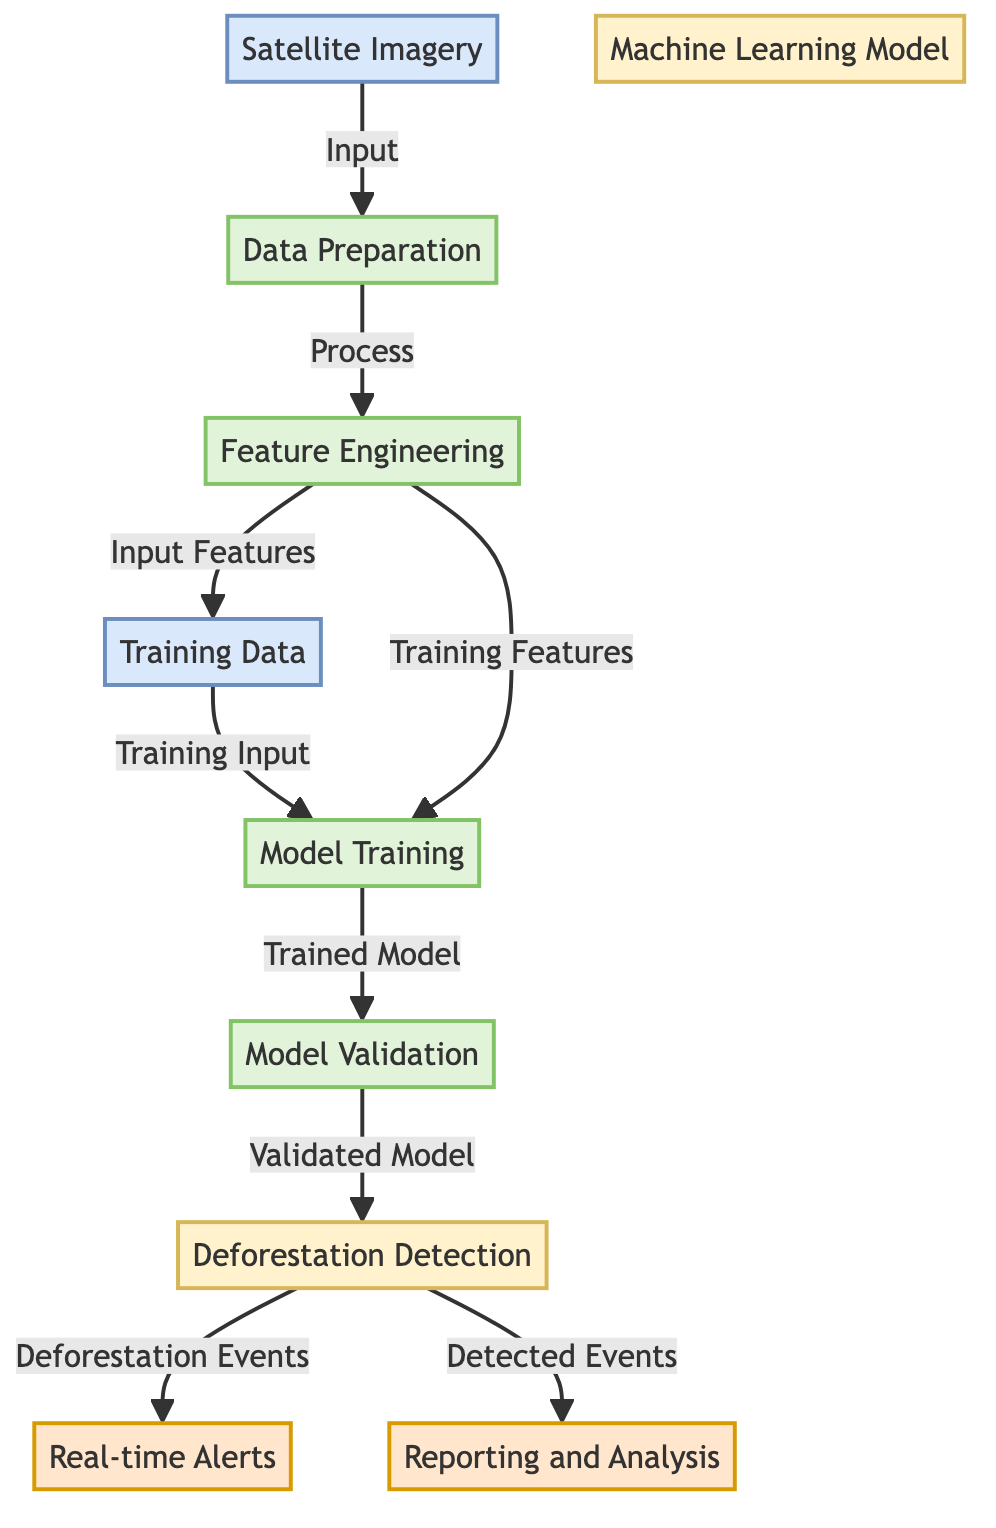what is the first step in the diagram? The first step in the diagram is "Satellite Imagery", which refers to the input data collected from satellites that is necessary for the entire process.
Answer: Satellite Imagery how many output nodes are there in the diagram? The diagram contains two output nodes: "Real-time Alerts" and "Reporting and Analysis," which provide results of the deforestation detection model.
Answer: 2 which process directly follows data preparation? The process that directly follows "Data Preparation" is "Feature Engineering," which involves transforming the prepared data into features suitable for model training.
Answer: Feature Engineering what is produced after model training? After "Model Training," the output is a "Trained Model," which is then used in the next step for validation.
Answer: Trained Model which step precedes notifications? The step that precedes "Real-time Alerts" is "Deforestation Detection," which identifies deforestation events from the validated model output before alerts can be generated.
Answer: Deforestation Detection how does feature engineering connect to model training? "Feature Engineering" provides input features to "Model Training" along with the training data, indicating both are essential for effectively training the machine learning model.
Answer: Training Features and Training Input what are the two outputs of deforestation detection? The two outputs from "Deforestation Detection" are "Real-time Alerts" and "Reporting and Analysis," indicating differentiated uses of detected deforestation events.
Answer: Real-time Alerts and Reporting and Analysis what type of model is represented in the diagram? The model type represented in the diagram is a "Machine Learning Model," which is designed to detect deforestation from satellite data using algorithms.
Answer: Machine Learning Model 